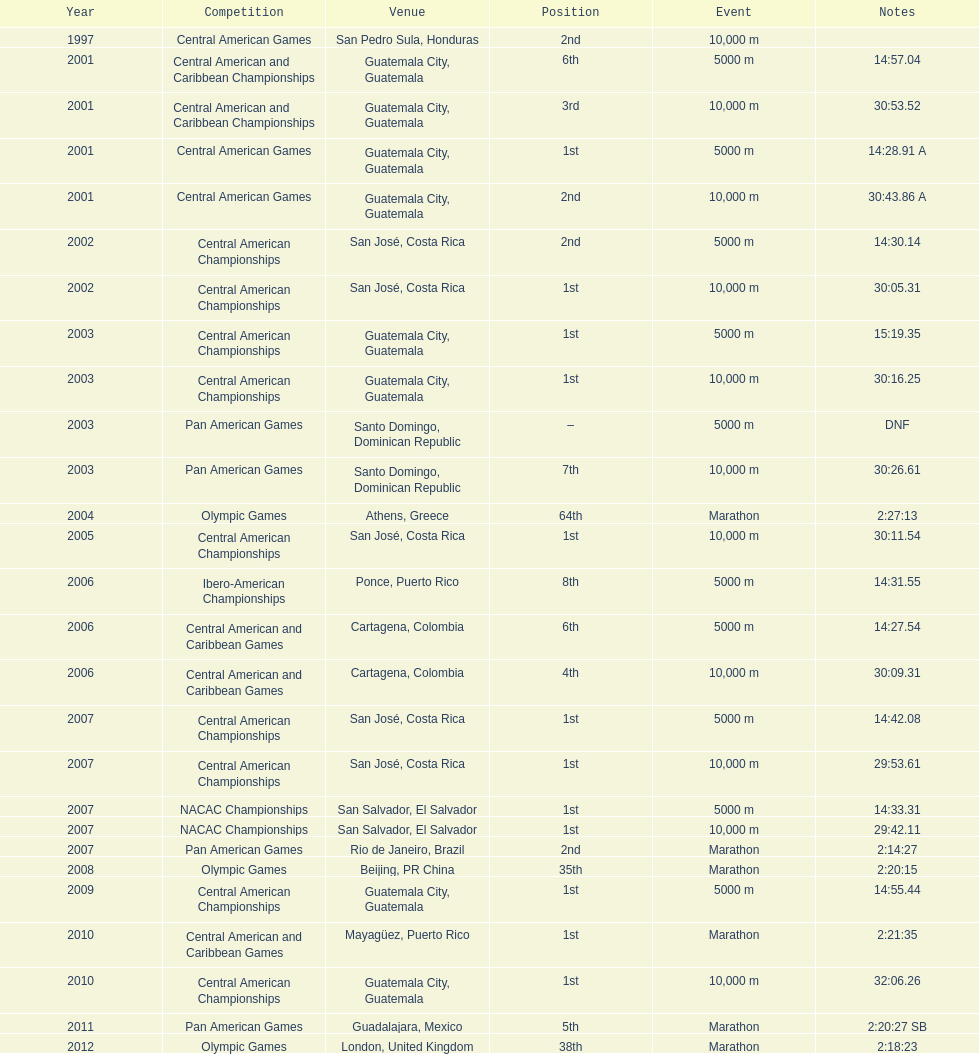Where was the only 64th position held? Athens, Greece. 